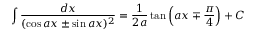Convert formula to latex. <formula><loc_0><loc_0><loc_500><loc_500>\int { \frac { d x } { ( \cos a x \pm \sin a x ) ^ { 2 } } } = { \frac { 1 } { 2 a } } \tan \left ( a x \mp { \frac { \pi } { 4 } } \right ) + C</formula> 